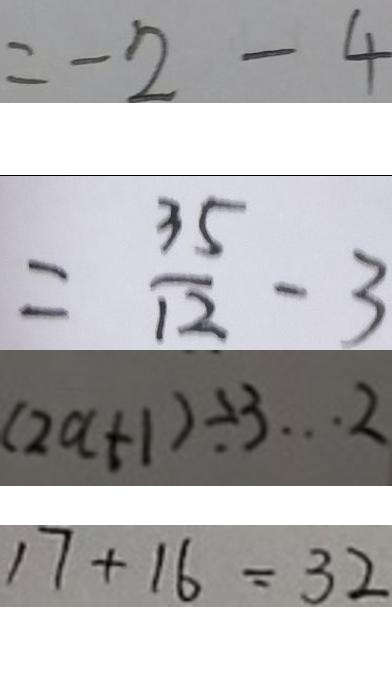Convert formula to latex. <formula><loc_0><loc_0><loc_500><loc_500>= - 2 - 4 
 = \frac { 3 5 } { 1 2 } - 3 
 ( 2 a + 1 ) \div 3 \cdots 2 
 1 7 + 1 6 = 3 2</formula> 